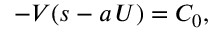Convert formula to latex. <formula><loc_0><loc_0><loc_500><loc_500>- V ( s - a \, U ) = C _ { 0 } ,</formula> 